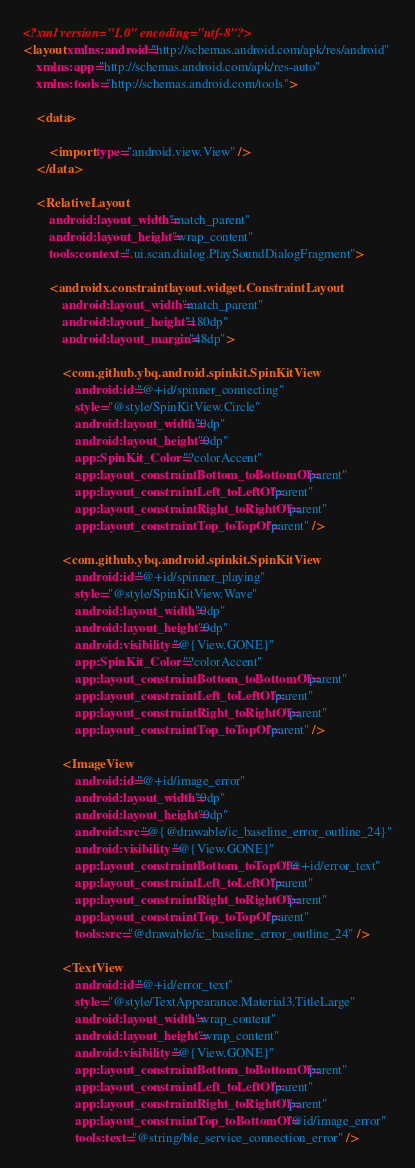<code> <loc_0><loc_0><loc_500><loc_500><_XML_><?xml version="1.0" encoding="utf-8"?>
<layout xmlns:android="http://schemas.android.com/apk/res/android"
    xmlns:app="http://schemas.android.com/apk/res-auto"
    xmlns:tools="http://schemas.android.com/tools">

    <data>

        <import type="android.view.View" />
    </data>

    <RelativeLayout
        android:layout_width="match_parent"
        android:layout_height="wrap_content"
        tools:context=".ui.scan.dialog.PlaySoundDialogFragment">

        <androidx.constraintlayout.widget.ConstraintLayout
            android:layout_width="match_parent"
            android:layout_height="180dp"
            android:layout_margin="48dp">

            <com.github.ybq.android.spinkit.SpinKitView
                android:id="@+id/spinner_connecting"
                style="@style/SpinKitView.Circle"
                android:layout_width="0dp"
                android:layout_height="0dp"
                app:SpinKit_Color="?colorAccent"
                app:layout_constraintBottom_toBottomOf="parent"
                app:layout_constraintLeft_toLeftOf="parent"
                app:layout_constraintRight_toRightOf="parent"
                app:layout_constraintTop_toTopOf="parent" />

            <com.github.ybq.android.spinkit.SpinKitView
                android:id="@+id/spinner_playing"
                style="@style/SpinKitView.Wave"
                android:layout_width="0dp"
                android:layout_height="0dp"
                android:visibility="@{View.GONE}"
                app:SpinKit_Color="?colorAccent"
                app:layout_constraintBottom_toBottomOf="parent"
                app:layout_constraintLeft_toLeftOf="parent"
                app:layout_constraintRight_toRightOf="parent"
                app:layout_constraintTop_toTopOf="parent" />

            <ImageView
                android:id="@+id/image_error"
                android:layout_width="0dp"
                android:layout_height="0dp"
                android:src="@{@drawable/ic_baseline_error_outline_24}"
                android:visibility="@{View.GONE}"
                app:layout_constraintBottom_toTopOf="@+id/error_text"
                app:layout_constraintLeft_toLeftOf="parent"
                app:layout_constraintRight_toRightOf="parent"
                app:layout_constraintTop_toTopOf="parent"
                tools:src="@drawable/ic_baseline_error_outline_24" />

            <TextView
                android:id="@+id/error_text"
                style="@style/TextAppearance.Material3.TitleLarge"
                android:layout_width="wrap_content"
                android:layout_height="wrap_content"
                android:visibility="@{View.GONE}"
                app:layout_constraintBottom_toBottomOf="parent"
                app:layout_constraintLeft_toLeftOf="parent"
                app:layout_constraintRight_toRightOf="parent"
                app:layout_constraintTop_toBottomOf="@id/image_error"
                tools:text="@string/ble_service_connection_error" />

</code> 